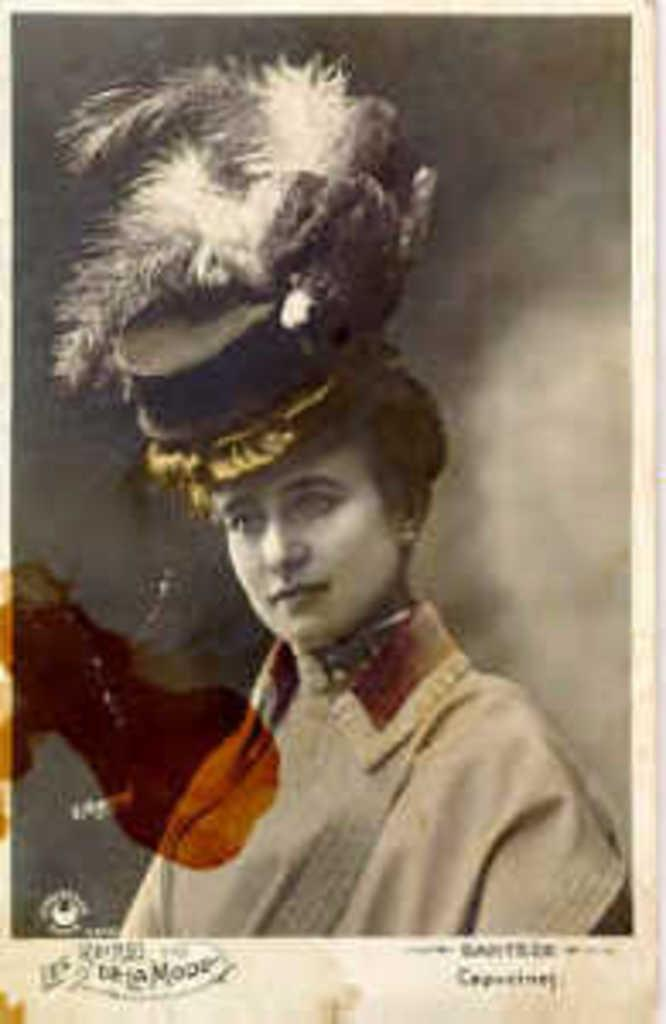What type of object is in the image? There is an old photograph in the image. Who is depicted in the photograph? The photograph is of a woman. Does the woman in the photograph have a tail? There is no indication in the image that the woman has a tail, as humans do not have tails. 